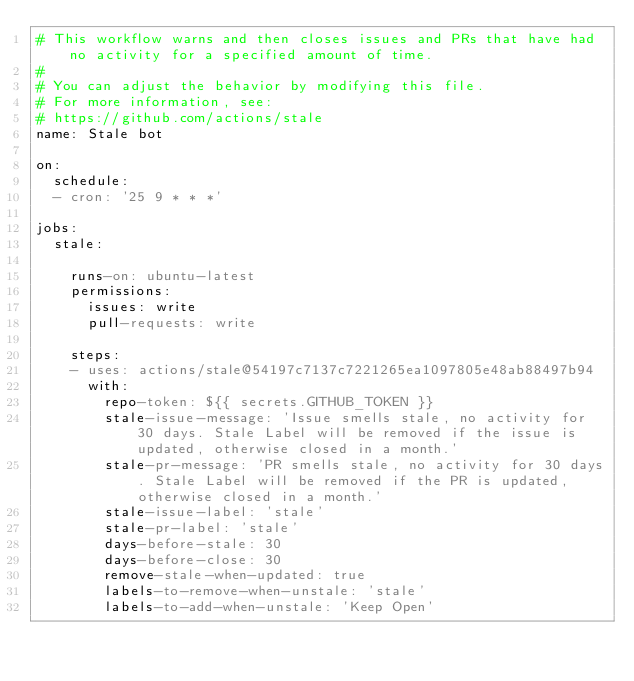<code> <loc_0><loc_0><loc_500><loc_500><_YAML_># This workflow warns and then closes issues and PRs that have had no activity for a specified amount of time.
#
# You can adjust the behavior by modifying this file.
# For more information, see:
# https://github.com/actions/stale
name: Stale bot

on:
  schedule:
  - cron: '25 9 * * *'

jobs:
  stale:

    runs-on: ubuntu-latest
    permissions:
      issues: write
      pull-requests: write

    steps:
    - uses: actions/stale@54197c7137c7221265ea1097805e48ab88497b94
      with:
        repo-token: ${{ secrets.GITHUB_TOKEN }}
        stale-issue-message: 'Issue smells stale, no activity for 30 days. Stale Label will be removed if the issue is updated, otherwise closed in a month.'
        stale-pr-message: 'PR smells stale, no activity for 30 days. Stale Label will be removed if the PR is updated, otherwise closed in a month.'
        stale-issue-label: 'stale'
        stale-pr-label: 'stale'
        days-before-stale: 30
        days-before-close: 30
        remove-stale-when-updated: true
        labels-to-remove-when-unstale: 'stale'
        labels-to-add-when-unstale: 'Keep Open'
</code> 